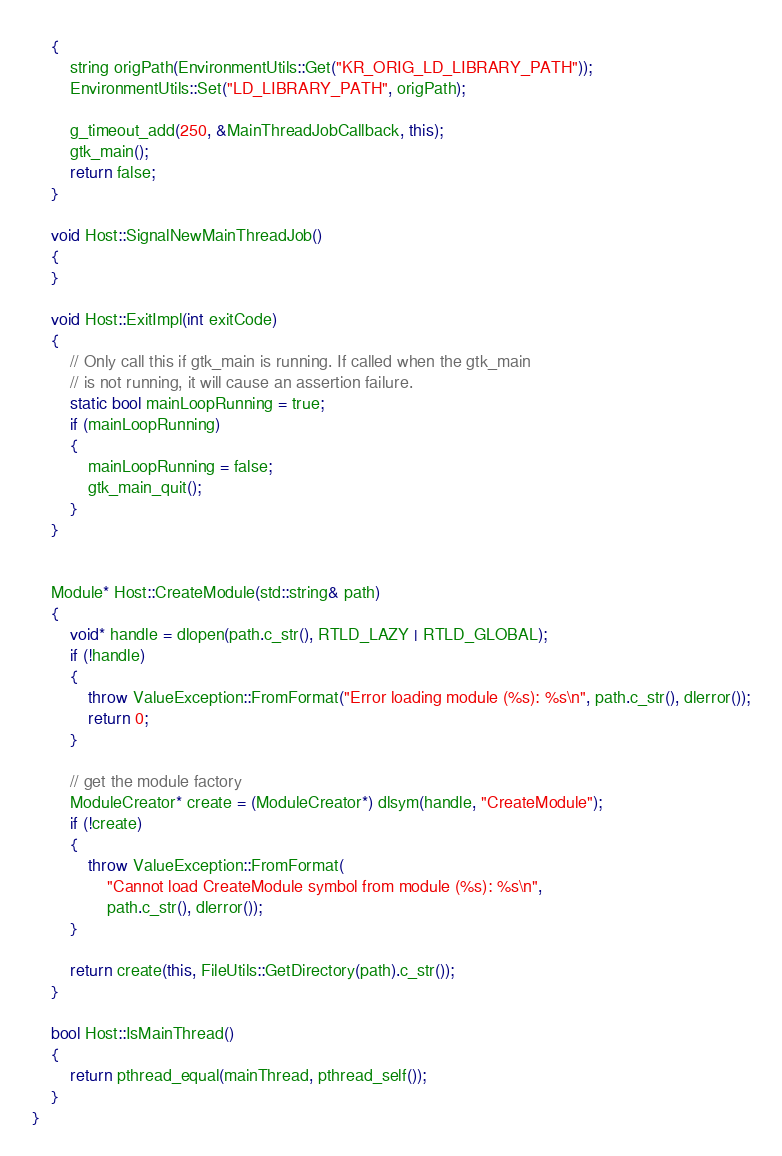Convert code to text. <code><loc_0><loc_0><loc_500><loc_500><_C++_>	{
		string origPath(EnvironmentUtils::Get("KR_ORIG_LD_LIBRARY_PATH"));
		EnvironmentUtils::Set("LD_LIBRARY_PATH", origPath);

		g_timeout_add(250, &MainThreadJobCallback, this);
		gtk_main();
		return false;
	}

	void Host::SignalNewMainThreadJob()
	{
	}

	void Host::ExitImpl(int exitCode)
	{
		// Only call this if gtk_main is running. If called when the gtk_main
		// is not running, it will cause an assertion failure.
		static bool mainLoopRunning = true;
		if (mainLoopRunning)
		{
			mainLoopRunning = false;
			gtk_main_quit();
		}
	}


	Module* Host::CreateModule(std::string& path)
	{
		void* handle = dlopen(path.c_str(), RTLD_LAZY | RTLD_GLOBAL);
		if (!handle)
		{
			throw ValueException::FromFormat("Error loading module (%s): %s\n", path.c_str(), dlerror());
			return 0;
		}

		// get the module factory
		ModuleCreator* create = (ModuleCreator*) dlsym(handle, "CreateModule");
		if (!create)
		{
			throw ValueException::FromFormat(
				"Cannot load CreateModule symbol from module (%s): %s\n",
				path.c_str(), dlerror());
		}

		return create(this, FileUtils::GetDirectory(path).c_str());
	}

	bool Host::IsMainThread()
	{
		return pthread_equal(mainThread, pthread_self());
	}
}
</code> 